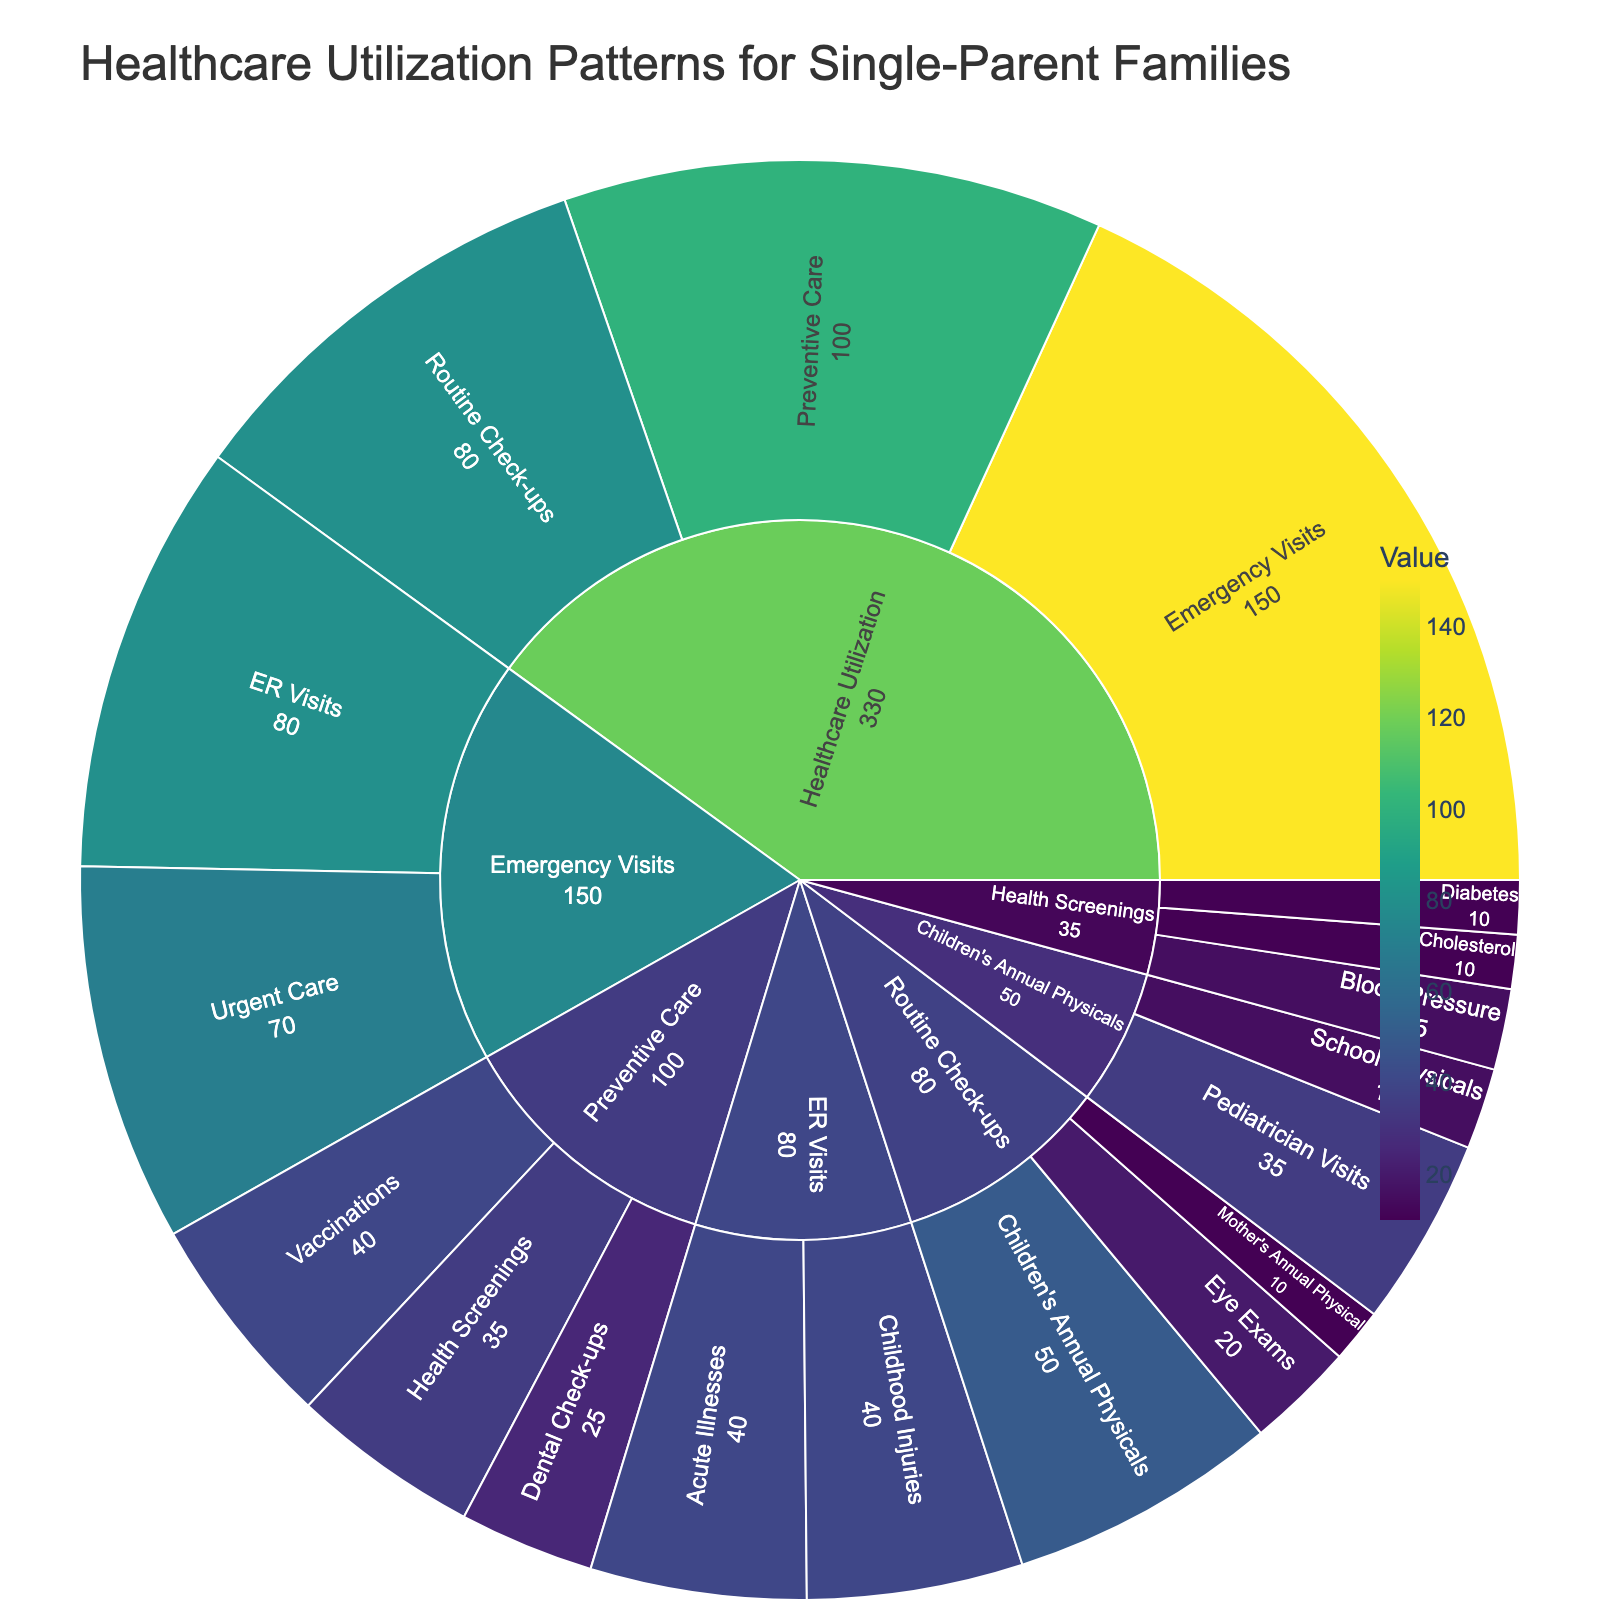What's the most common type of healthcare utilization among single-parent families? By examining the plot, we see that 'Emergency Visits' have the largest segment, indicating they are the most common type of healthcare utilization.
Answer: Emergency Visits How many total values are there for Preventive Care? The categories under 'Preventive Care' are 'Vaccinations' (40), 'Health Screenings' (35), and 'Dental Check-ups' (25). Summing these up: 40 + 35 + 25 = 100.
Answer: 100 Are children's annual physicals more frequent than mother's annual physicals? The plot shows that 'Children's Annual Physicals' have a value of 50, while 'Mother's Annual Physical' has a value of 10. Since 50 > 10, children's annual physicals are more frequent.
Answer: Yes What is the least common type of preventative care? By examining the segments under 'Preventive Care,' 'Dental Check-ups' have the smallest value (25), making it the least common type of preventative care.
Answer: Dental Check-ups What's the total value for Emergency Visits? Adding up the values for 'Urgent Care' (70) and 'ER Visits' (80) gives a total of 70 + 80 = 150 for 'Emergency Visits'.
Answer: 150 Which category has more values: Health Screenings or ER Visits? Health Screenings have values of 'Blood Pressure' (15), 'Cholesterol' (10), and 'Diabetes' (10), summing to 15 + 10 + 10 = 35. ER Visits have 'Childhood Injuries' (40) and 'Acute Illnesses' (40), summing to 40 + 40 = 80. Since 80 > 35, ER Visits have more values.
Answer: ER Visits By how much do Emergency Visits exceed Routine Check-ups? Emergency Visits total 150, while Routine Check-ups total 80. The difference is 150 - 80 = 70.
Answer: 70 What's the largest subcategory under Routine Check-ups? Under the 'Routine Check-ups’ category, the subcategory with the highest value is 'Children's Annual Physicals' with a value of 50.
Answer: Children's Annual Physicals What are the values for the categories under Health Screenings? 'Blood Pressure' has a value of 15, 'Cholesterol' has 10, and 'Diabetes' also has 10.
Answer: 15, 10, 10 Are Vaccinations more frequent than both Blood Pressure screenings and Dental Check-ups combined? The total value for 'Blood Pressure' (15) and 'Dental Check-ups' (25) is 15 + 25 = 40. 'Vaccinations' also have a value of 40, equal to the combined total of Blood Pressure and Dental Check-ups.
Answer: No 